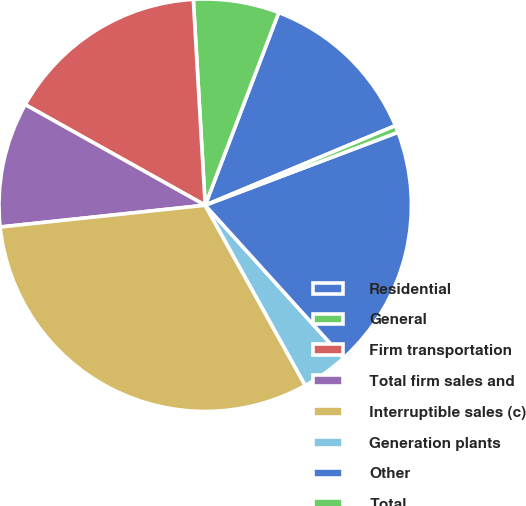Convert chart. <chart><loc_0><loc_0><loc_500><loc_500><pie_chart><fcel>Residential<fcel>General<fcel>Firm transportation<fcel>Total firm sales and<fcel>Interruptible sales (c)<fcel>Generation plants<fcel>Other<fcel>Total<nl><fcel>12.89%<fcel>6.72%<fcel>15.97%<fcel>9.8%<fcel>31.38%<fcel>3.64%<fcel>19.05%<fcel>0.55%<nl></chart> 